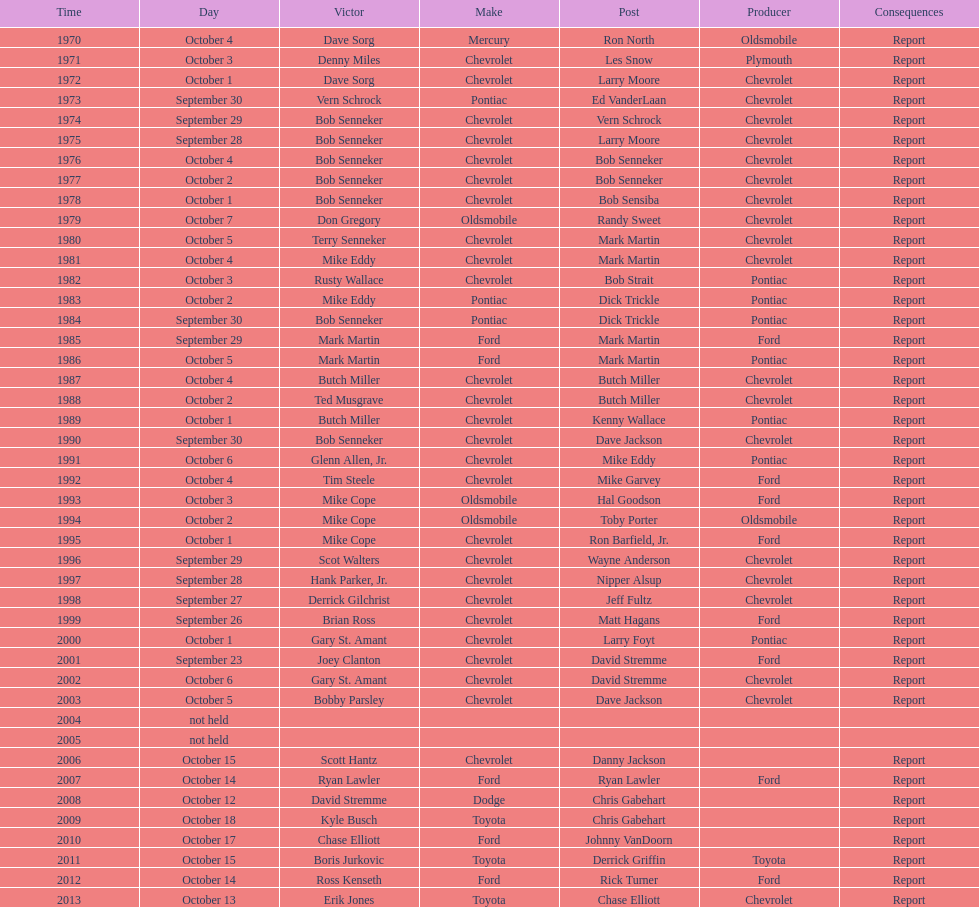How many consecutive wins did bob senneker have? 5. 